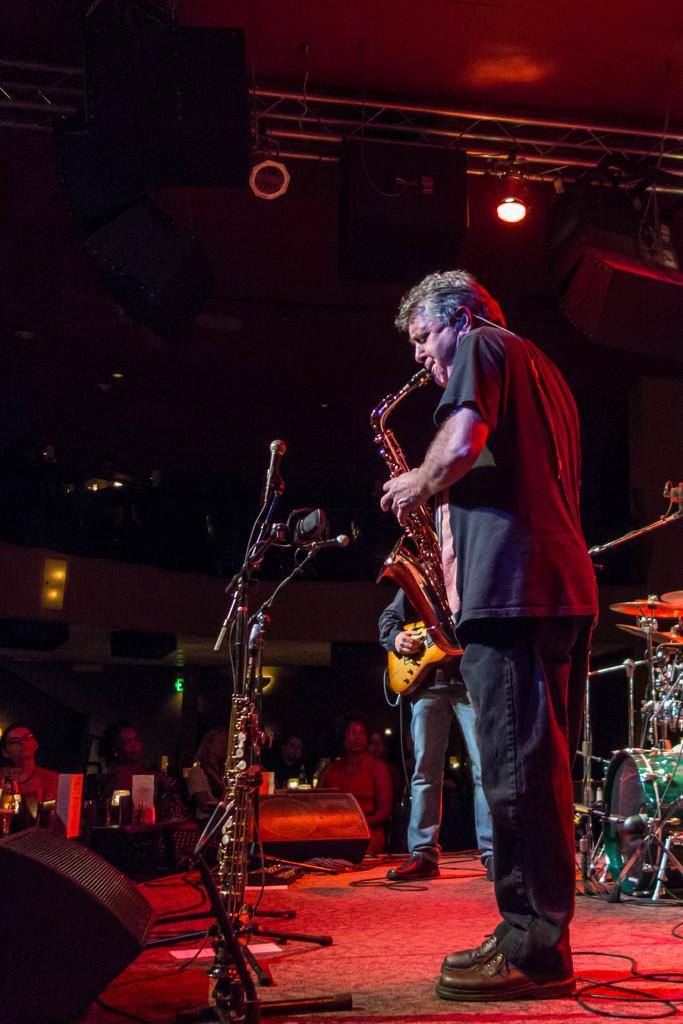What are the two people in the image doing? There is a person playing a saxophone and a person playing a guitar in the image. Where are the people playing their instruments located? Both people are standing on a dais. How many toes can be seen on the person playing the guitar in the image? There is no information about toes in the image, as it focuses on the people playing musical instruments. 